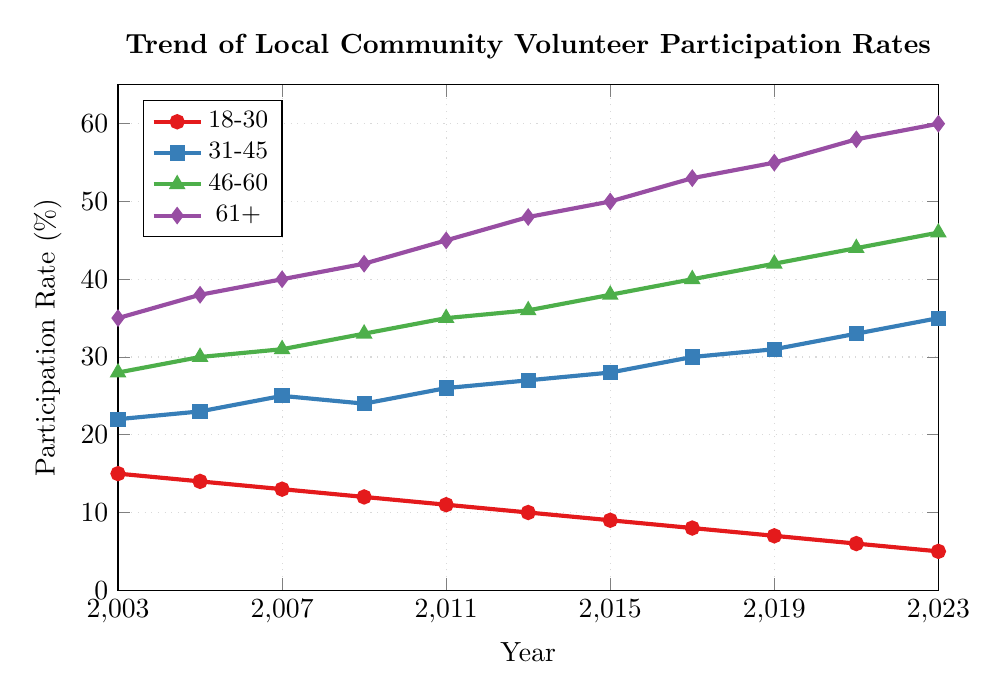What age group had the highest participation rate in 2023? The participation rates for 2023 for all age groups are shown at the end point of their respective lines. The group with the highest value is 61+, which reached 60%.
Answer: 61+ How did the participation rate for the 18-30 age group change from 2003 to 2023? The rate in 2003 for the 18-30 group was 15%, and in 2023 it dropped to 5%. The change can be calculated by subtracting the final value from the initial value: 15% - 5% = 10%.
Answer: Decreased by 10% Which age group showed the most consistent increase in participation over the years? To identify the most consistent increase, we look for a line that continually rises without any dips. The 61+ group shows a consistent rise from 35% in 2003 to 60% in 2023.
Answer: 61+ In which year did the 31-45 age group see a notable dip in their participation rate, and what was the rate before and after the dip? The 31-45 age group dipped slightly from 25% in 2007 to 24% in 2009. Before the dip, in 2007, it was 25%, and after the dip, in 2011, it rose to 26%.
Answer: 2009; before: 25%, after: 24% What is the overall trend for the 46-60 age group from 2003 to 2023? Observing the points for the 46-60 age group, the values consistently increase from 28% in 2003 to 46% in 2023. This illustrates an overall increasing trend.
Answer: Increasing Between 2003 and 2023, which age group had the highest increase in participation rate, and by how much? Comparing the initial and final values for each age group: 
- 18-30: 15% to 5% 
- 31-45: 22% to 35%
- 46-60: 28% to 46%
- 61+: 35% to 60%
The 61+ group increased the most from 35% to 60%, which is an increase of 25%.
Answer: 61+; increased by 25% Which age group has the most significant decline in participation rate? Looking at the participation rates from 2003 to 2023, the 18-30 age group declined from 15% to 5%, which is a decline of 10%, the most significant decline among all age groups.
Answer: 18-30 